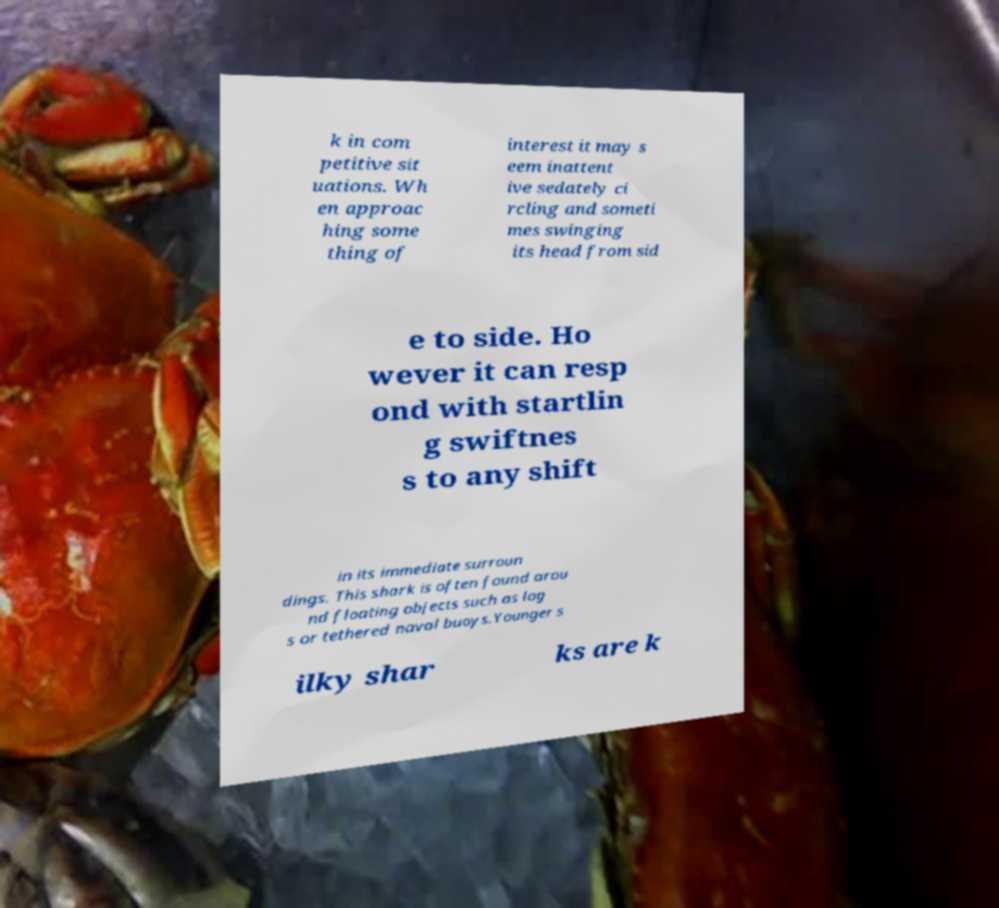What messages or text are displayed in this image? I need them in a readable, typed format. k in com petitive sit uations. Wh en approac hing some thing of interest it may s eem inattent ive sedately ci rcling and someti mes swinging its head from sid e to side. Ho wever it can resp ond with startlin g swiftnes s to any shift in its immediate surroun dings. This shark is often found arou nd floating objects such as log s or tethered naval buoys.Younger s ilky shar ks are k 